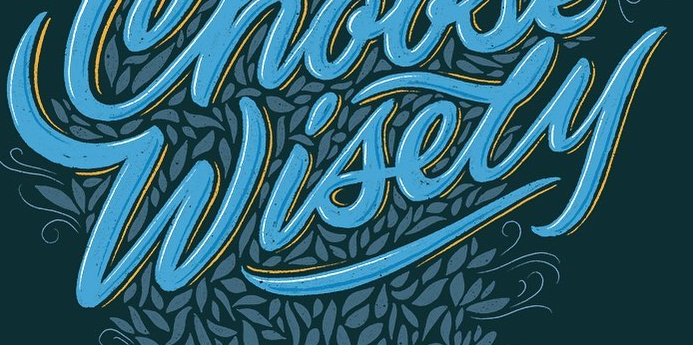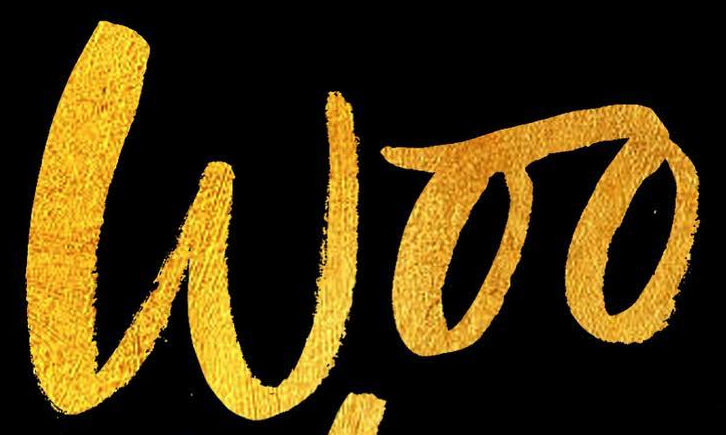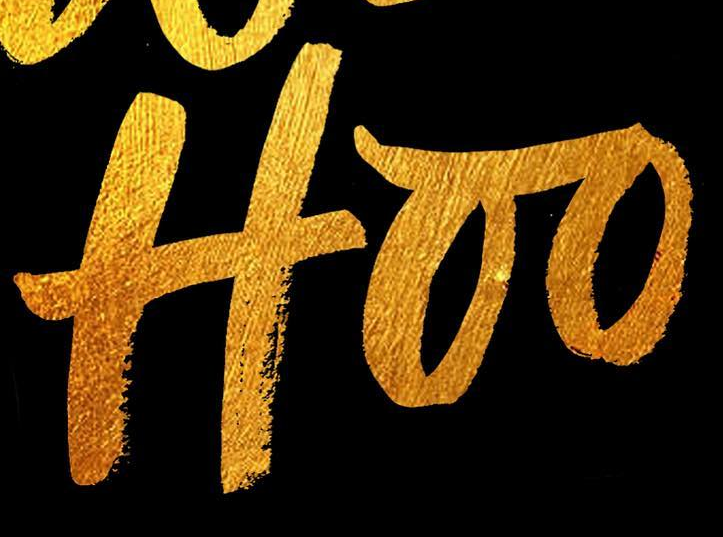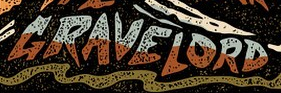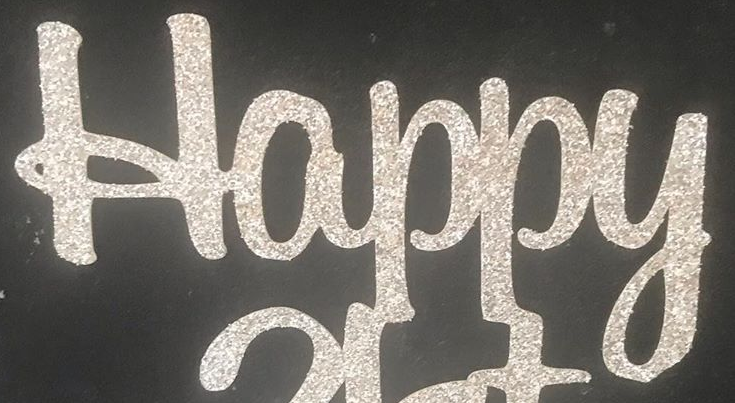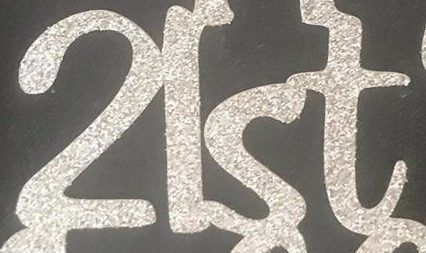Read the text from these images in sequence, separated by a semicolon. Wisely; Woo; Hoo; GRAVELORD; Happy; 2lst 